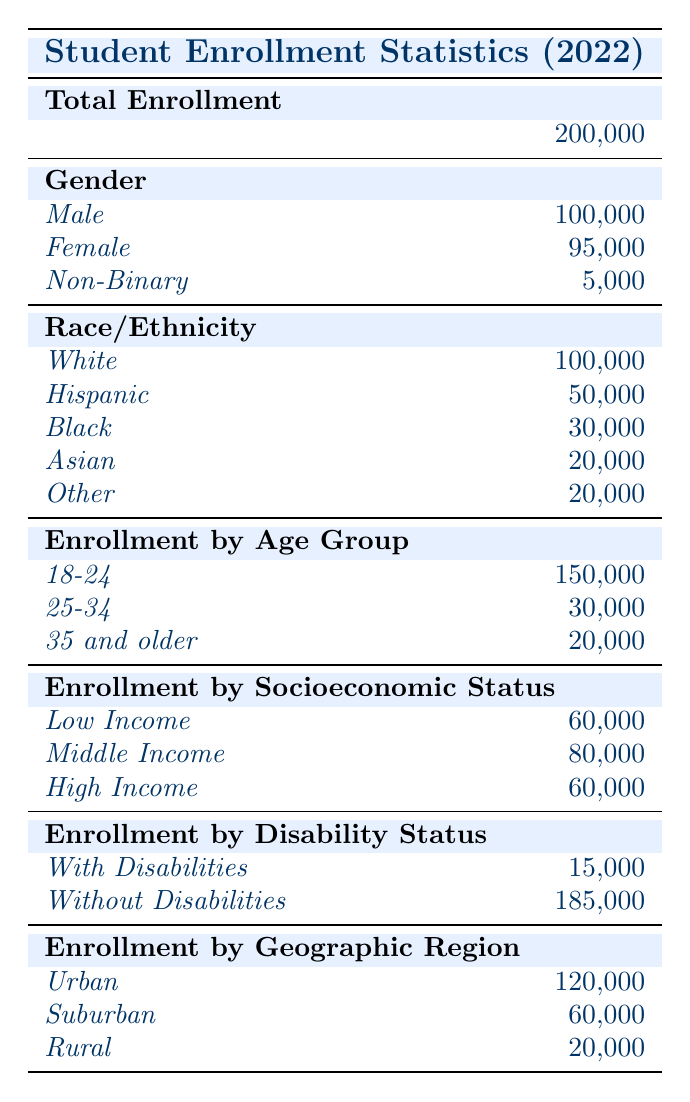What is the total student enrollment for the 2022 academic year? The total enrollment is clearly stated in the table under "Total Enrollment." The value listed is 200,000.
Answer: 200,000 How many female students were enrolled? The table lists the number of female students under the "Gender" category, which is indicated as 95,000.
Answer: 95,000 What is the difference in enrollment between male and non-binary students? The number of male students is 100,000, and the number of non-binary students is 5,000. The difference is calculated as 100,000 - 5,000 = 95,000.
Answer: 95,000 How many students are enrolled in the age group 25-34? The table shows that the enrollment for the age group 25-34 is specifically listed as 30,000.
Answer: 30,000 What percentage of students are classified as Low Income? The number of Low Income students is 60,000 out of a total enrollment of 200,000. The percentage is calculated as (60,000 / 200,000) * 100 = 30%.
Answer: 30% How many students are without disabilities? This information is found in the "Enrollment by Disability Status" section of the table, which lists 185,000 students as without disabilities.
Answer: 185,000 What is the total enrollment of students from racial/ethnic minority groups? From the "Race/Ethnicity" section, the total for minority groups (Hispanic, Black, Asian, Other) is calculated as 50,000 + 30,000 + 20,000 + 20,000 = 120,000.
Answer: 120,000 What is the ratio of students from Urban to Rural regions? The number of Urban students is 120,000 and Rural students is 20,000. The ratio is calculated as 120,000:20,000, which simplifies to 6:1.
Answer: 6:1 Is the enrollment of students aged 35 and older less than those who are Low Income? The table shows 20,000 students aged 35 and older and 60,000 students classified as Low Income. Since 20,000 is less than 60,000, the answer is yes.
Answer: Yes How many more students are enrolled in Urban areas than in Suburban areas? The table lists 120,000 students in Urban areas and 60,000 in Suburban areas. The difference is calculated as 120,000 - 60,000 = 60,000.
Answer: 60,000 What is the combined enrollment of students in the age groups 18-24 and 25-34? The table shows 150,000 students aged 18-24 and 30,000 aged 25-34. The combined enrollment is calculated as 150,000 + 30,000 = 180,000.
Answer: 180,000 